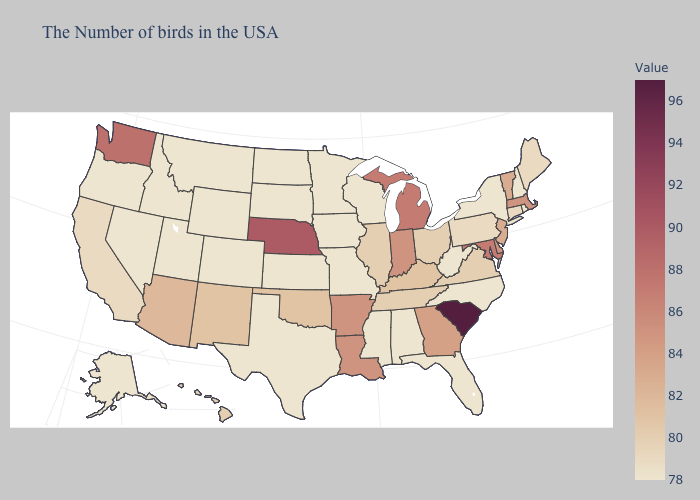Which states hav the highest value in the Northeast?
Keep it brief. Massachusetts. Among the states that border Michigan , does Wisconsin have the lowest value?
Keep it brief. Yes. Which states have the lowest value in the South?
Be succinct. North Carolina, West Virginia, Florida, Alabama, Mississippi, Texas. 